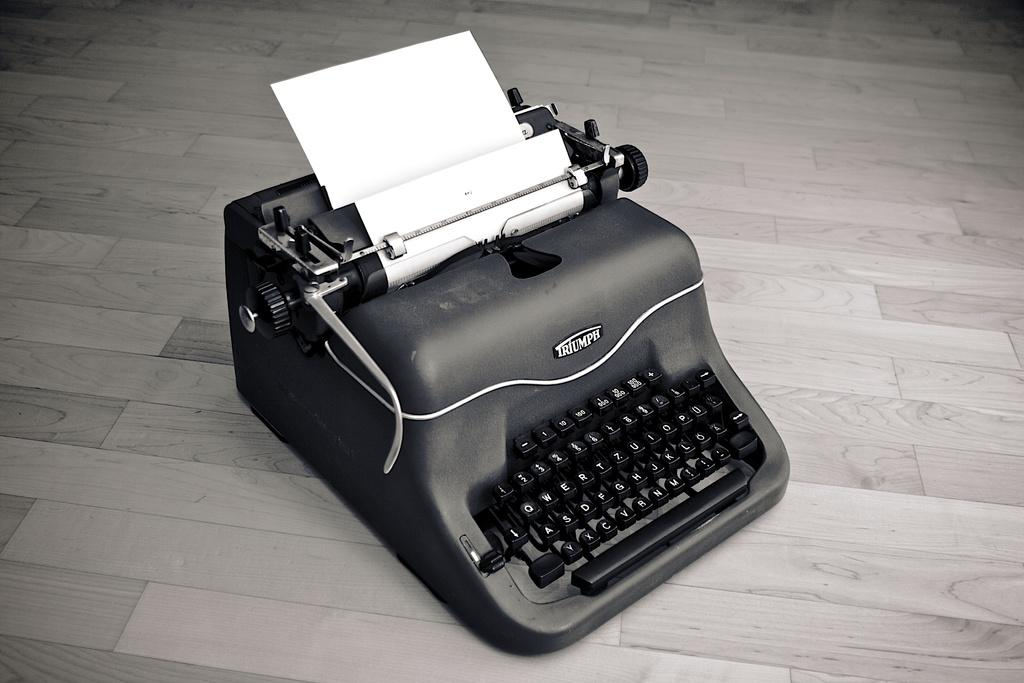<image>
Render a clear and concise summary of the photo. An old black Triumph typewriter sits on a gray wood floor. 